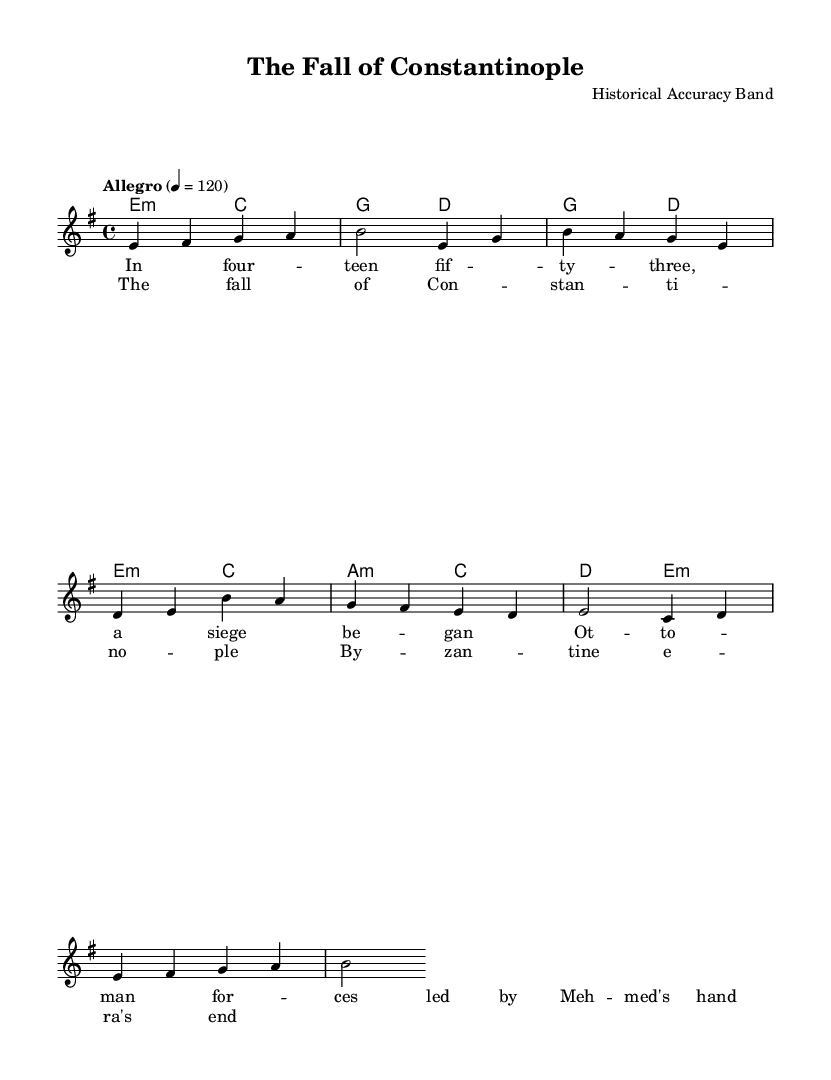What is the key signature of this music? The key signature is indicated with sharps or flats at the beginning of the staff. In this case, it shows one sharp, which corresponds to E minor (relative minor of G major).
Answer: E minor What is the time signature of this music? The time signature appears next to the key signature at the beginning of the staff. It is 4/4, meaning there are four beats in each measure and the quarter note gets one beat.
Answer: 4/4 What is the tempo marking for this piece? The tempo is generally indicated right after the clef and key signature. Here, it is noted as "Allegro" with a metronome marking of 120 beats per minute, which denotes a fast pace.
Answer: Allegro What are the first three notes of the melody? The melody is presented in a relative pitch format. By analyzing the first measure, we see the notes are E, F sharp, and G.
Answer: E, F sharp, G How many measures are in the verse section? The verse, shown in the lyrics, includes a total of eight measures if we count each rhythmic grouping of the melody from the provided notes and their respective harmonies.
Answer: Eight Which historical event is depicted in the lyrics? The lyrics reference the historical siege that began in 1453, led by Ottoman forces under Mehmed II, which resulted in the fall of Constantinople and the end of the Byzantine era.
Answer: The fall of Constantinople 